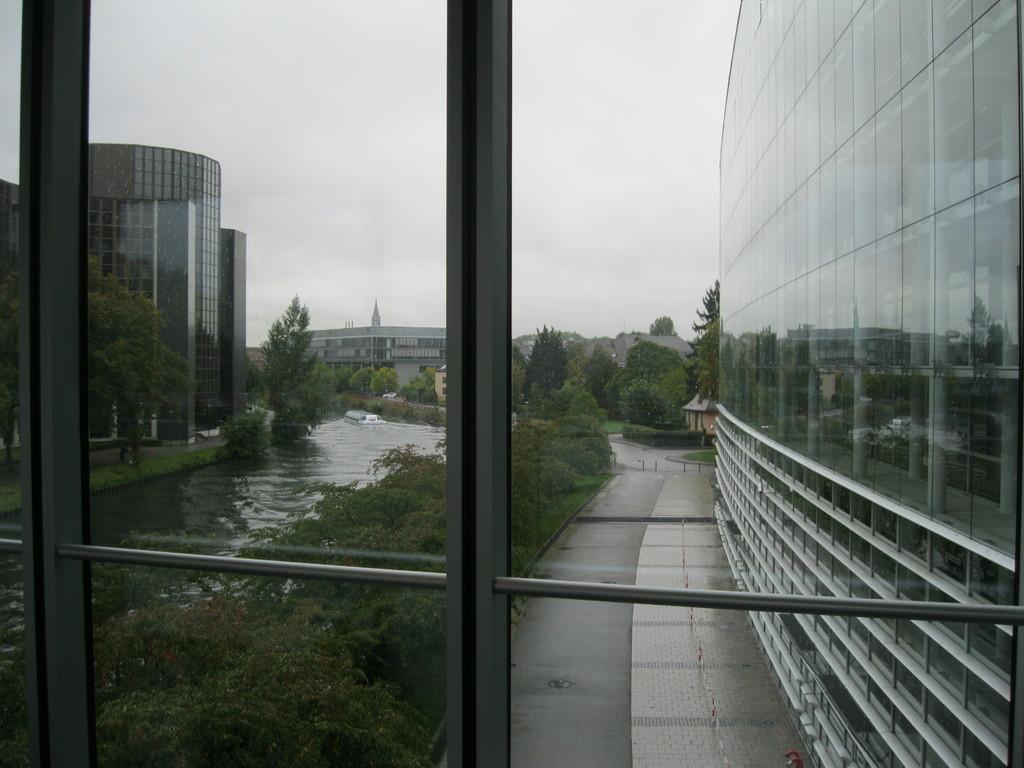Please provide a concise description of this image. In this picture we can see a lake, side we can see some buildings, trees. 